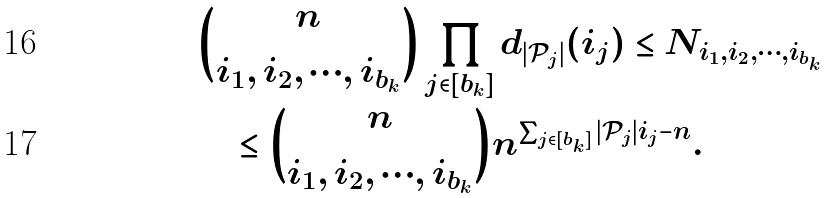Convert formula to latex. <formula><loc_0><loc_0><loc_500><loc_500>& { n \choose i _ { 1 } , i _ { 2 } , \cdots , i _ { b _ { k } } } \prod _ { j \in [ b _ { k } ] } d _ { | \mathcal { P } _ { j } | } ( i _ { j } ) \leq N _ { i _ { 1 } , i _ { 2 } , \cdots , i _ { b _ { k } } } \\ & \quad \leq { n \choose i _ { 1 } , i _ { 2 } , \cdots , i _ { b _ { k } } } n ^ { \sum _ { j \in [ b _ { k } ] } | \mathcal { P } _ { j } | i _ { j } - n } .</formula> 